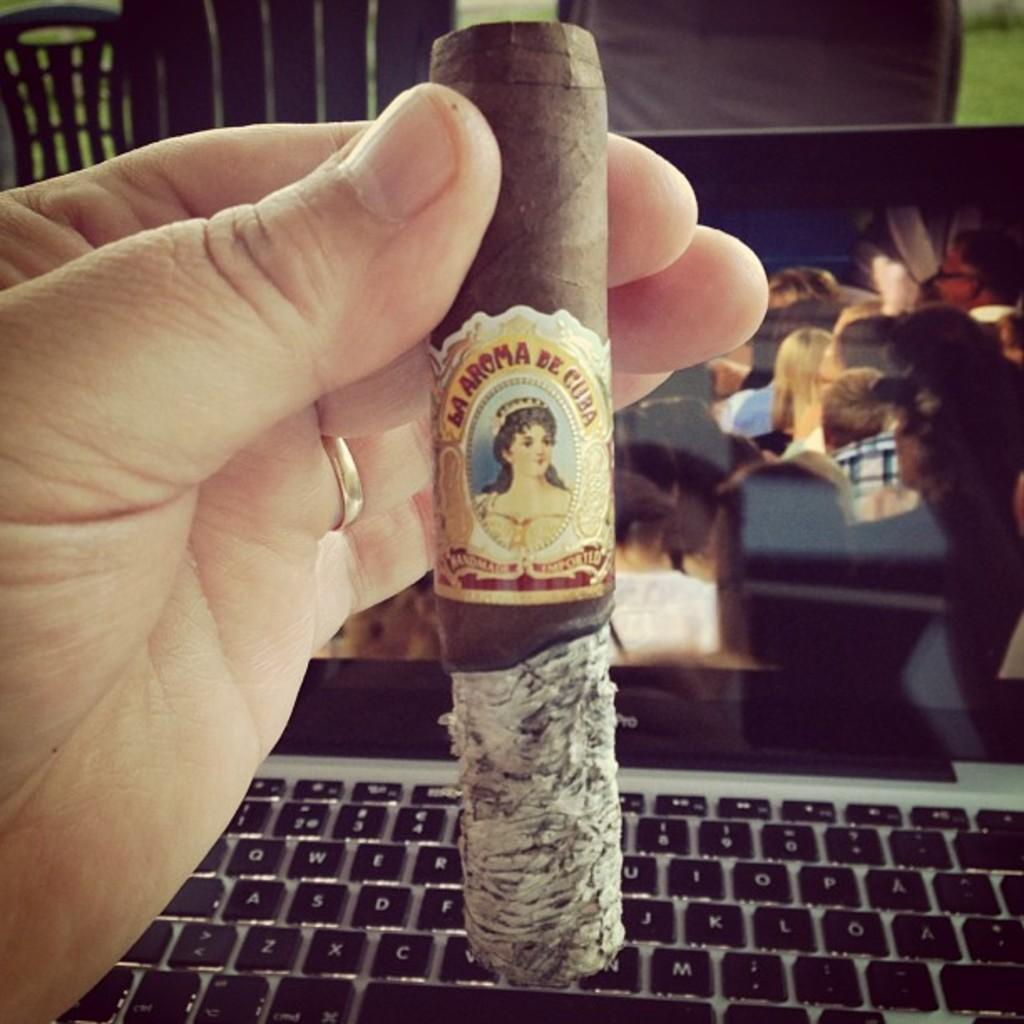<image>
Offer a succinct explanation of the picture presented. A hand holding a cigar reading M Aroma de cuba overtop a keyboard. 